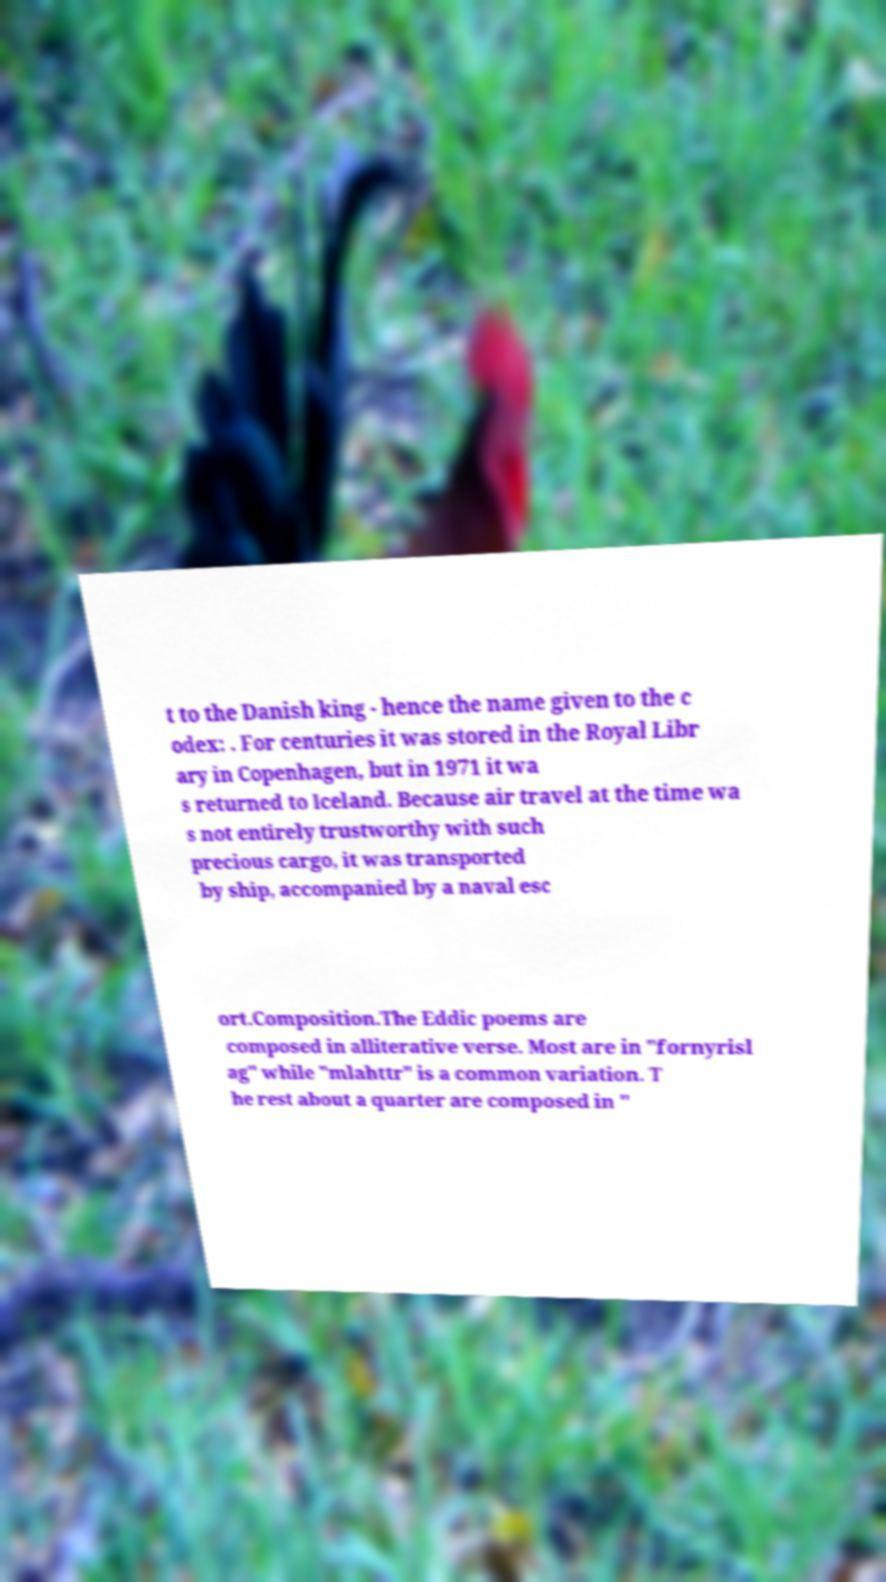Could you assist in decoding the text presented in this image and type it out clearly? t to the Danish king - hence the name given to the c odex: . For centuries it was stored in the Royal Libr ary in Copenhagen, but in 1971 it wa s returned to Iceland. Because air travel at the time wa s not entirely trustworthy with such precious cargo, it was transported by ship, accompanied by a naval esc ort.Composition.The Eddic poems are composed in alliterative verse. Most are in "fornyrisl ag" while "mlahttr" is a common variation. T he rest about a quarter are composed in " 